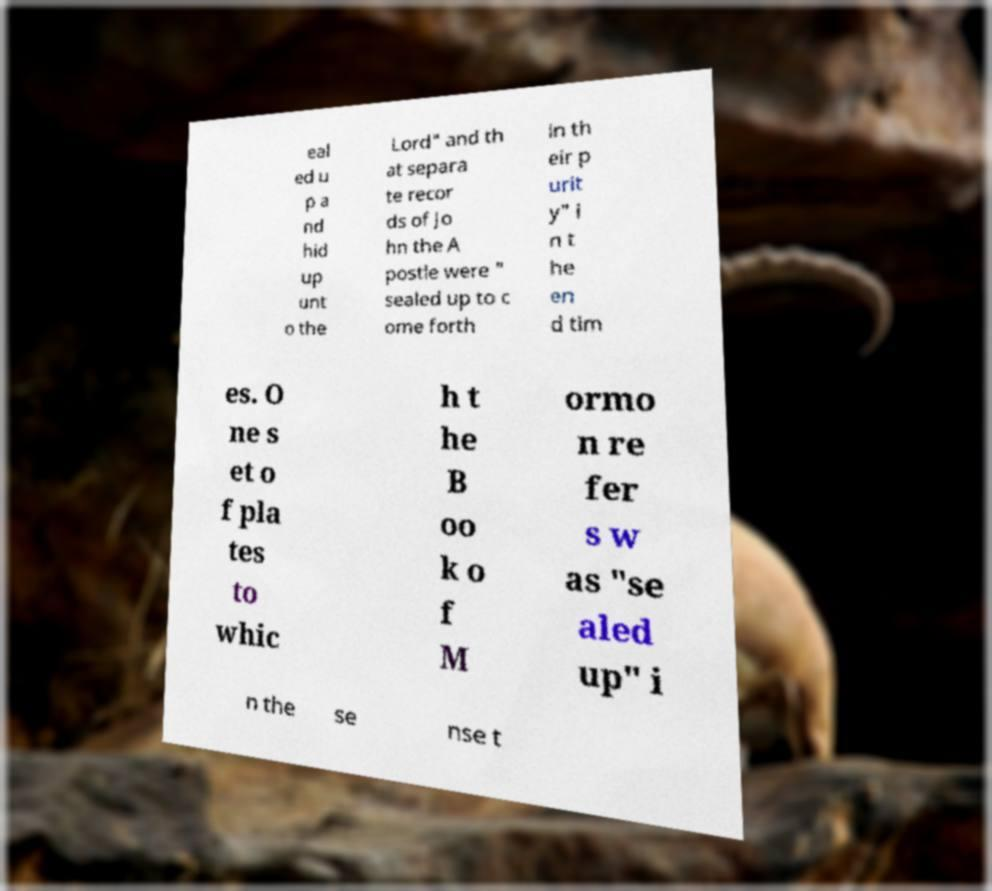Can you accurately transcribe the text from the provided image for me? eal ed u p a nd hid up unt o the Lord" and th at separa te recor ds of Jo hn the A postle were " sealed up to c ome forth in th eir p urit y" i n t he en d tim es. O ne s et o f pla tes to whic h t he B oo k o f M ormo n re fer s w as "se aled up" i n the se nse t 